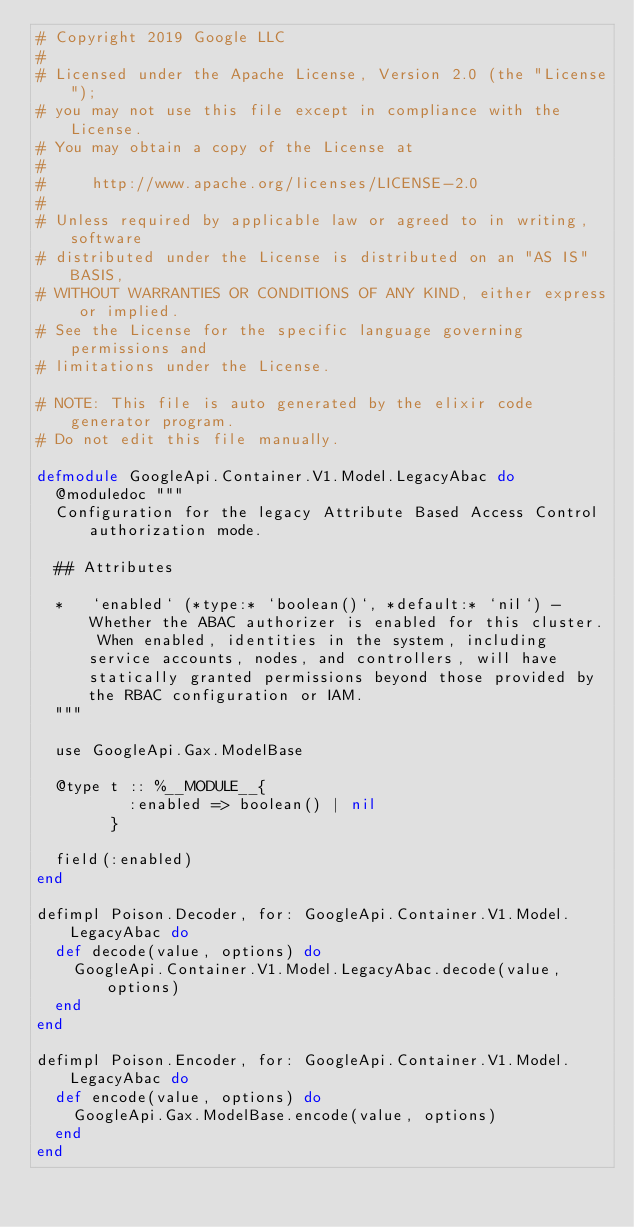Convert code to text. <code><loc_0><loc_0><loc_500><loc_500><_Elixir_># Copyright 2019 Google LLC
#
# Licensed under the Apache License, Version 2.0 (the "License");
# you may not use this file except in compliance with the License.
# You may obtain a copy of the License at
#
#     http://www.apache.org/licenses/LICENSE-2.0
#
# Unless required by applicable law or agreed to in writing, software
# distributed under the License is distributed on an "AS IS" BASIS,
# WITHOUT WARRANTIES OR CONDITIONS OF ANY KIND, either express or implied.
# See the License for the specific language governing permissions and
# limitations under the License.

# NOTE: This file is auto generated by the elixir code generator program.
# Do not edit this file manually.

defmodule GoogleApi.Container.V1.Model.LegacyAbac do
  @moduledoc """
  Configuration for the legacy Attribute Based Access Control authorization mode.

  ## Attributes

  *   `enabled` (*type:* `boolean()`, *default:* `nil`) - Whether the ABAC authorizer is enabled for this cluster. When enabled, identities in the system, including service accounts, nodes, and controllers, will have statically granted permissions beyond those provided by the RBAC configuration or IAM.
  """

  use GoogleApi.Gax.ModelBase

  @type t :: %__MODULE__{
          :enabled => boolean() | nil
        }

  field(:enabled)
end

defimpl Poison.Decoder, for: GoogleApi.Container.V1.Model.LegacyAbac do
  def decode(value, options) do
    GoogleApi.Container.V1.Model.LegacyAbac.decode(value, options)
  end
end

defimpl Poison.Encoder, for: GoogleApi.Container.V1.Model.LegacyAbac do
  def encode(value, options) do
    GoogleApi.Gax.ModelBase.encode(value, options)
  end
end
</code> 